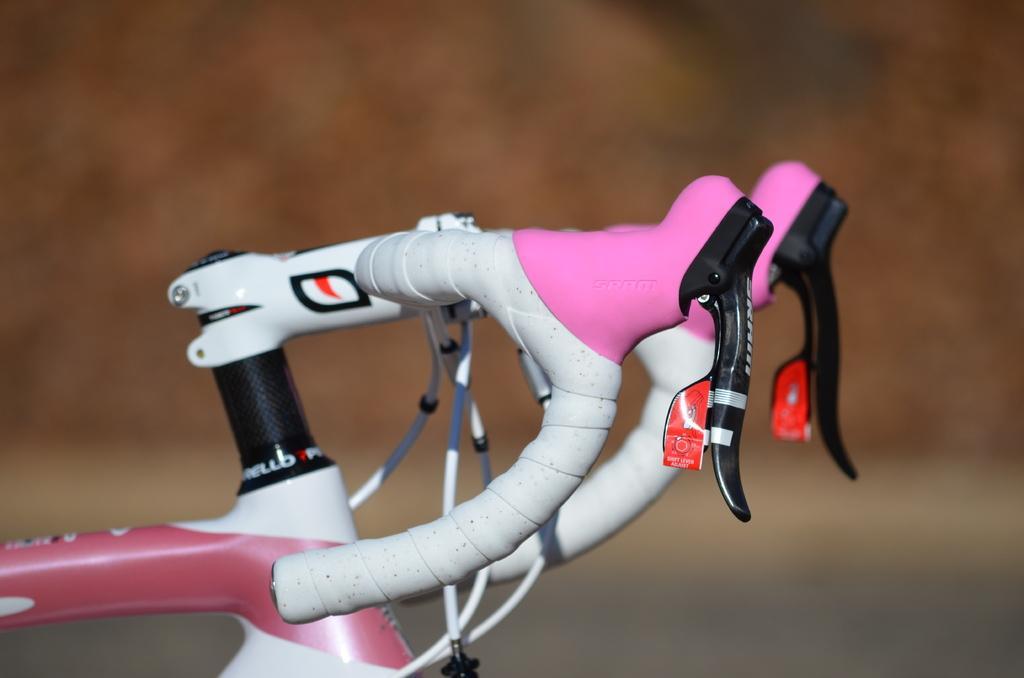Could you give a brief overview of what you see in this image? A picture of a bicycle handle with gears. Background it is blur. 